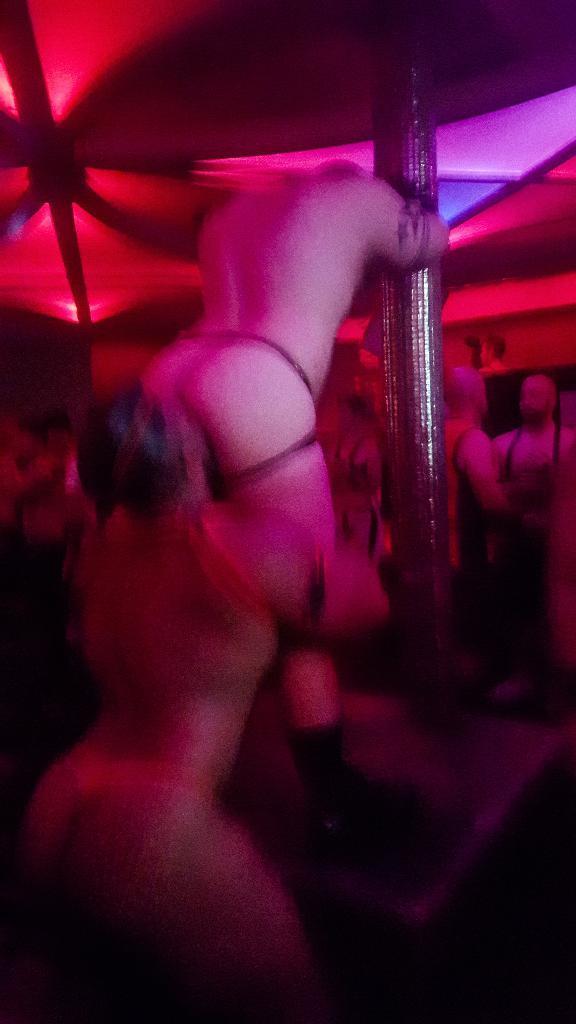How would you summarize this image in a sentence or two? In the picture I can see two persons are standing near the pole. The background of the image is slightly blurred, where we can see a few people standing and we can see lights. 